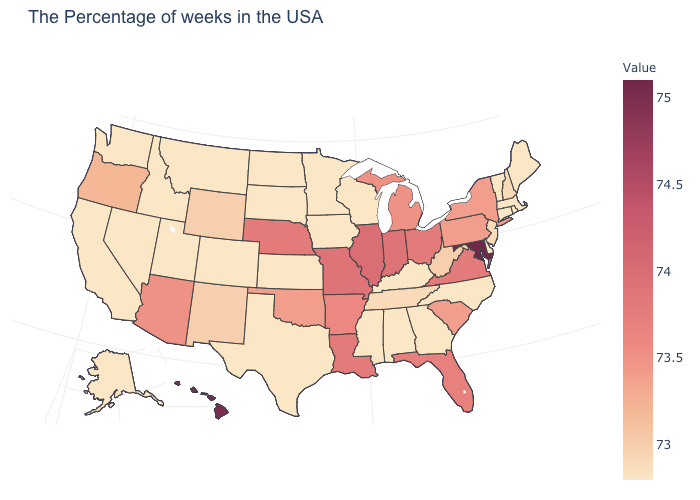Is the legend a continuous bar?
Concise answer only. Yes. Does Maryland have the highest value in the USA?
Write a very short answer. Yes. Which states hav the highest value in the South?
Quick response, please. Maryland. Which states have the lowest value in the USA?
Write a very short answer. Maine, Massachusetts, Rhode Island, Vermont, Connecticut, Delaware, North Carolina, Georgia, Kentucky, Alabama, Wisconsin, Mississippi, Minnesota, Iowa, Kansas, Texas, South Dakota, North Dakota, Colorado, Utah, Montana, Idaho, Nevada, California, Washington, Alaska. 